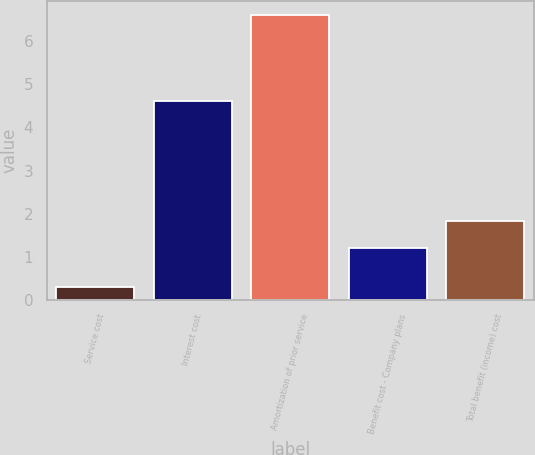<chart> <loc_0><loc_0><loc_500><loc_500><bar_chart><fcel>Service cost<fcel>Interest cost<fcel>Amortization of prior service<fcel>Benefit cost - Company plans<fcel>Total benefit (income) cost<nl><fcel>0.3<fcel>4.6<fcel>6.6<fcel>1.2<fcel>1.83<nl></chart> 